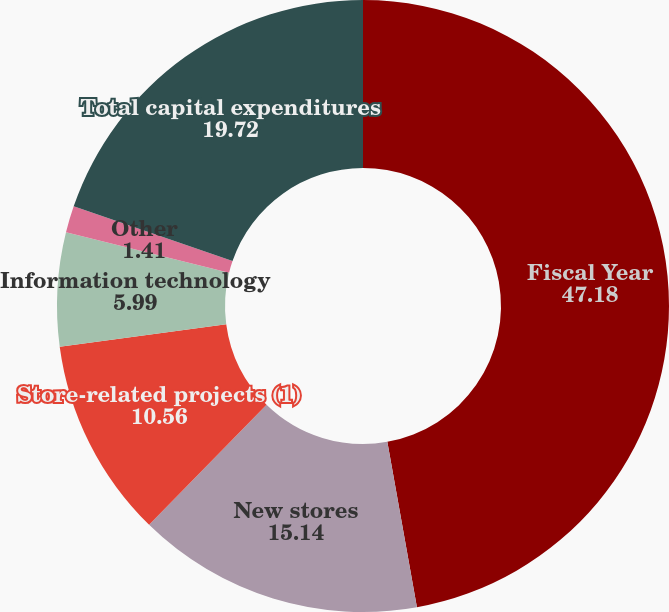<chart> <loc_0><loc_0><loc_500><loc_500><pie_chart><fcel>Fiscal Year<fcel>New stores<fcel>Store-related projects (1)<fcel>Information technology<fcel>Other<fcel>Total capital expenditures<nl><fcel>47.18%<fcel>15.14%<fcel>10.56%<fcel>5.99%<fcel>1.41%<fcel>19.72%<nl></chart> 